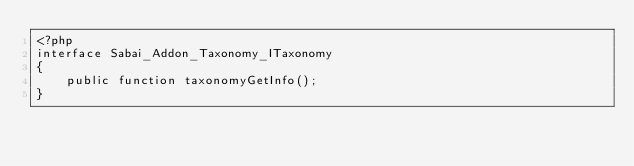<code> <loc_0><loc_0><loc_500><loc_500><_PHP_><?php
interface Sabai_Addon_Taxonomy_ITaxonomy
{
    public function taxonomyGetInfo();
}</code> 